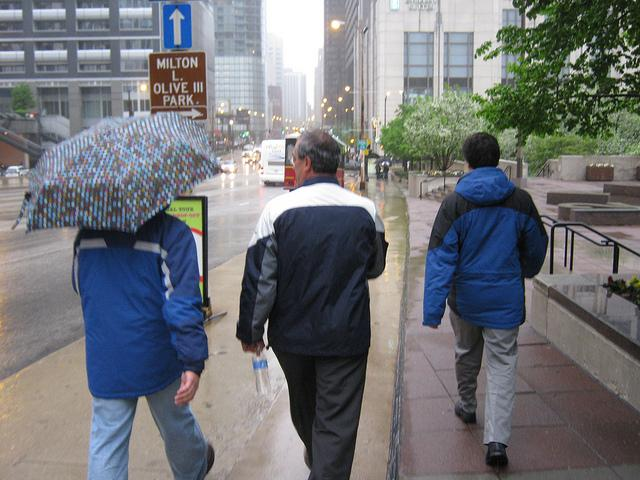What type of area is shown?

Choices:
A) forest
B) urban
C) coastal
D) rural urban 